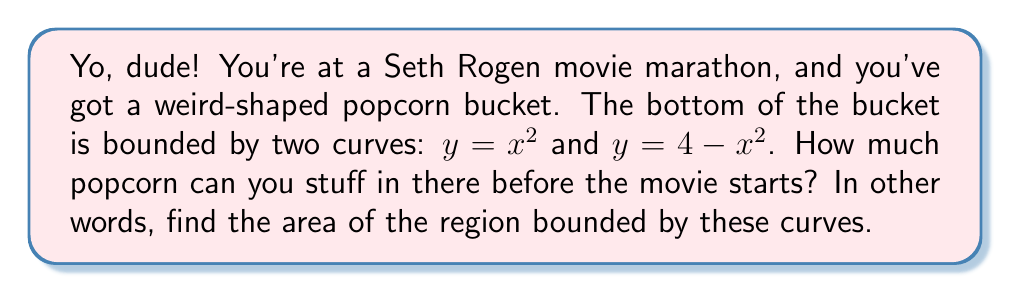Give your solution to this math problem. Alright, let's tackle this step-by-step:

1) First, we need to find the points of intersection of the two curves. Set them equal to each other:

   $$x^2 = 4 - x^2$$

2) Solve this equation:
   
   $$2x^2 = 4$$
   $$x^2 = 2$$
   $$x = \pm\sqrt{2}$$

3) So the curves intersect at $(-\sqrt{2}, 2)$ and $(\sqrt{2}, 2)$.

4) The area we're looking for is the difference between the upper curve and the lower curve, integrated from $-\sqrt{2}$ to $\sqrt{2}$:

   $$A = \int_{-\sqrt{2}}^{\sqrt{2}} [(4-x^2) - x^2] dx$$

5) Simplify the integrand:

   $$A = \int_{-\sqrt{2}}^{\sqrt{2}} [4 - 2x^2] dx$$

6) Integrate:

   $$A = [4x - \frac{2x^3}{3}]_{-\sqrt{2}}^{\sqrt{2}}$$

7) Evaluate the definite integral:

   $$A = (4\sqrt{2} - \frac{2(\sqrt{2})^3}{3}) - (-4\sqrt{2} - \frac{2(-\sqrt{2})^3}{3})$$

8) Simplify:

   $$A = 8\sqrt{2} - \frac{4\sqrt{8}}{3} = 8\sqrt{2} - \frac{4\sqrt{2}\sqrt{4}}{3} = 8\sqrt{2} - \frac{8\sqrt{2}}{3} = \frac{16\sqrt{2}}{3}$$
Answer: $\frac{16\sqrt{2}}{3}$ square units 